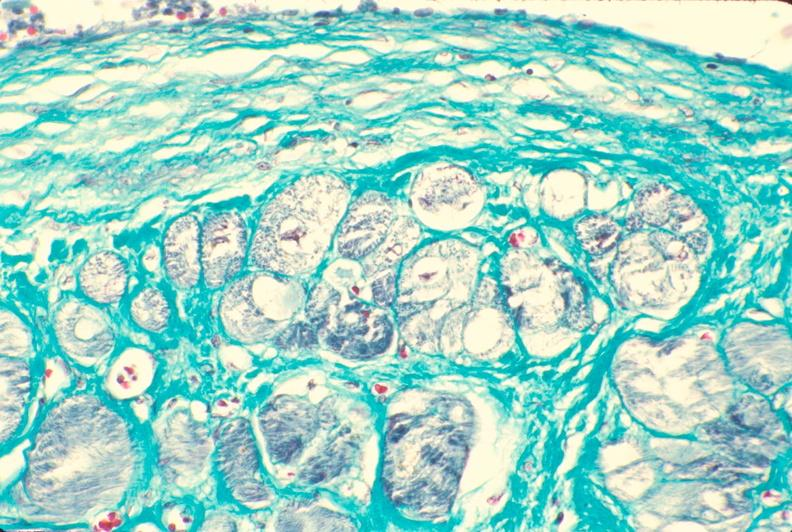what is present?
Answer the question using a single word or phrase. Cardiovascular 